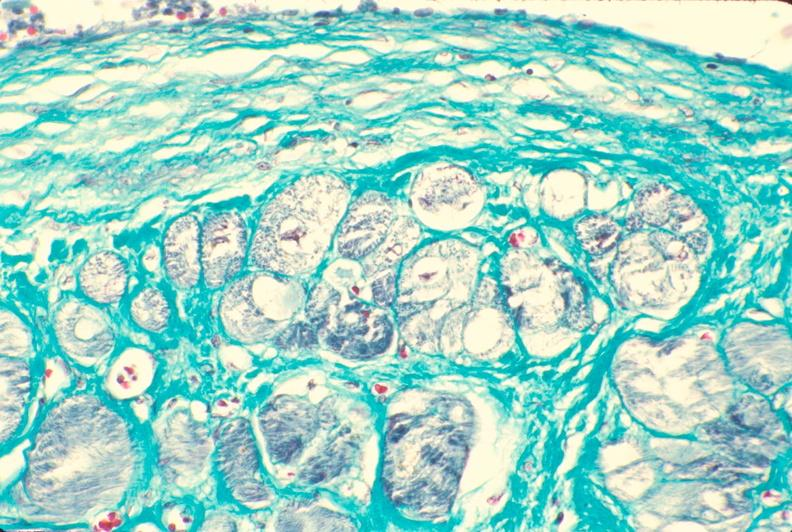what is present?
Answer the question using a single word or phrase. Cardiovascular 